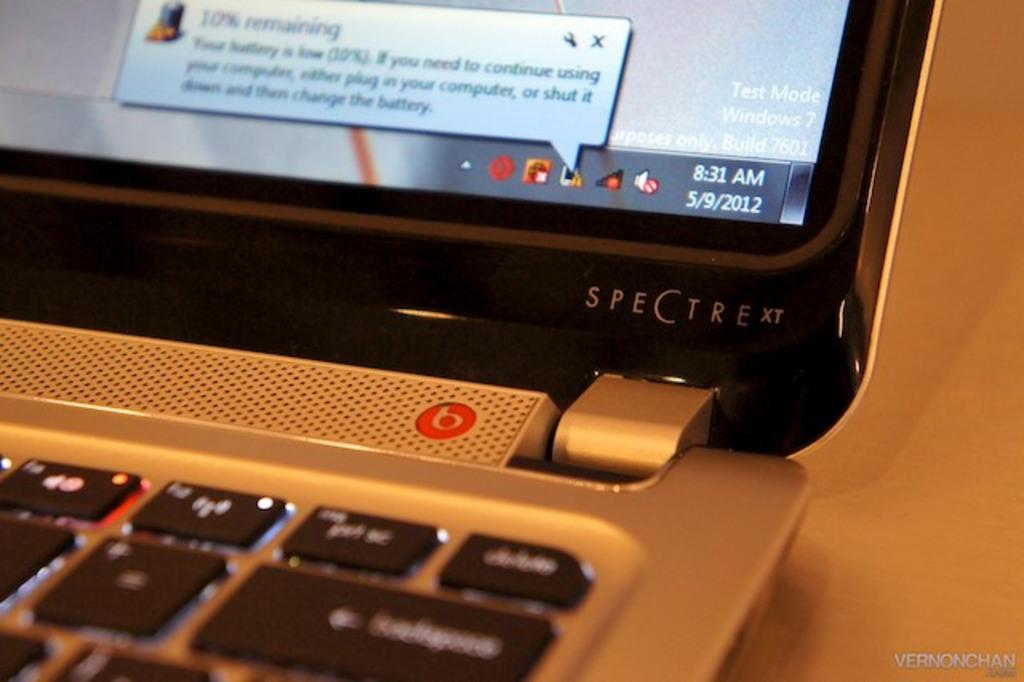What time is on the screen?
Ensure brevity in your answer.  8:31 am. What is the type or model of the laptop?
Provide a succinct answer. Spectre xt. 